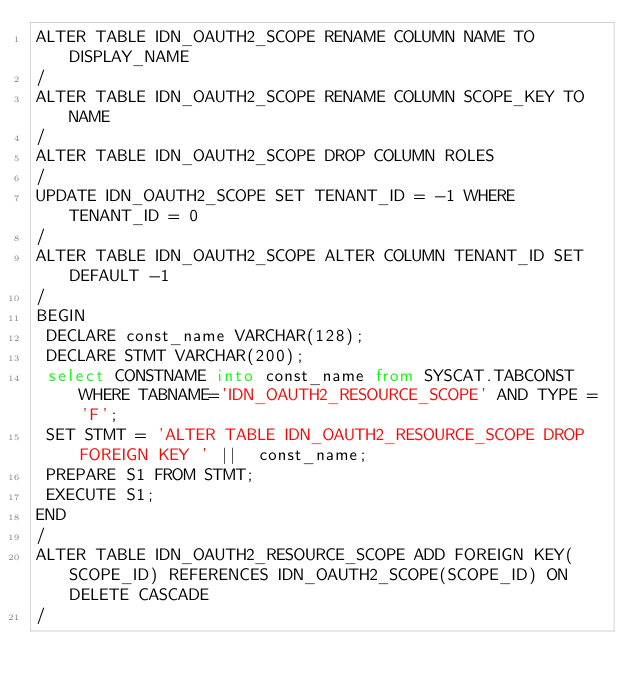Convert code to text. <code><loc_0><loc_0><loc_500><loc_500><_SQL_>ALTER TABLE IDN_OAUTH2_SCOPE RENAME COLUMN NAME TO DISPLAY_NAME
/
ALTER TABLE IDN_OAUTH2_SCOPE RENAME COLUMN SCOPE_KEY TO NAME
/
ALTER TABLE IDN_OAUTH2_SCOPE DROP COLUMN ROLES
/
UPDATE IDN_OAUTH2_SCOPE SET TENANT_ID = -1 WHERE TENANT_ID = 0
/
ALTER TABLE IDN_OAUTH2_SCOPE ALTER COLUMN TENANT_ID SET DEFAULT -1
/
BEGIN
 DECLARE const_name VARCHAR(128);
 DECLARE STMT VARCHAR(200);
 select CONSTNAME into const_name from SYSCAT.TABCONST WHERE TABNAME='IDN_OAUTH2_RESOURCE_SCOPE' AND TYPE = 'F';
 SET STMT = 'ALTER TABLE IDN_OAUTH2_RESOURCE_SCOPE DROP FOREIGN KEY ' ||  const_name;
 PREPARE S1 FROM STMT;
 EXECUTE S1;
END
/
ALTER TABLE IDN_OAUTH2_RESOURCE_SCOPE ADD FOREIGN KEY(SCOPE_ID) REFERENCES IDN_OAUTH2_SCOPE(SCOPE_ID) ON DELETE CASCADE
/
</code> 